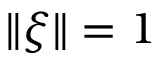<formula> <loc_0><loc_0><loc_500><loc_500>\| \xi \| = 1</formula> 